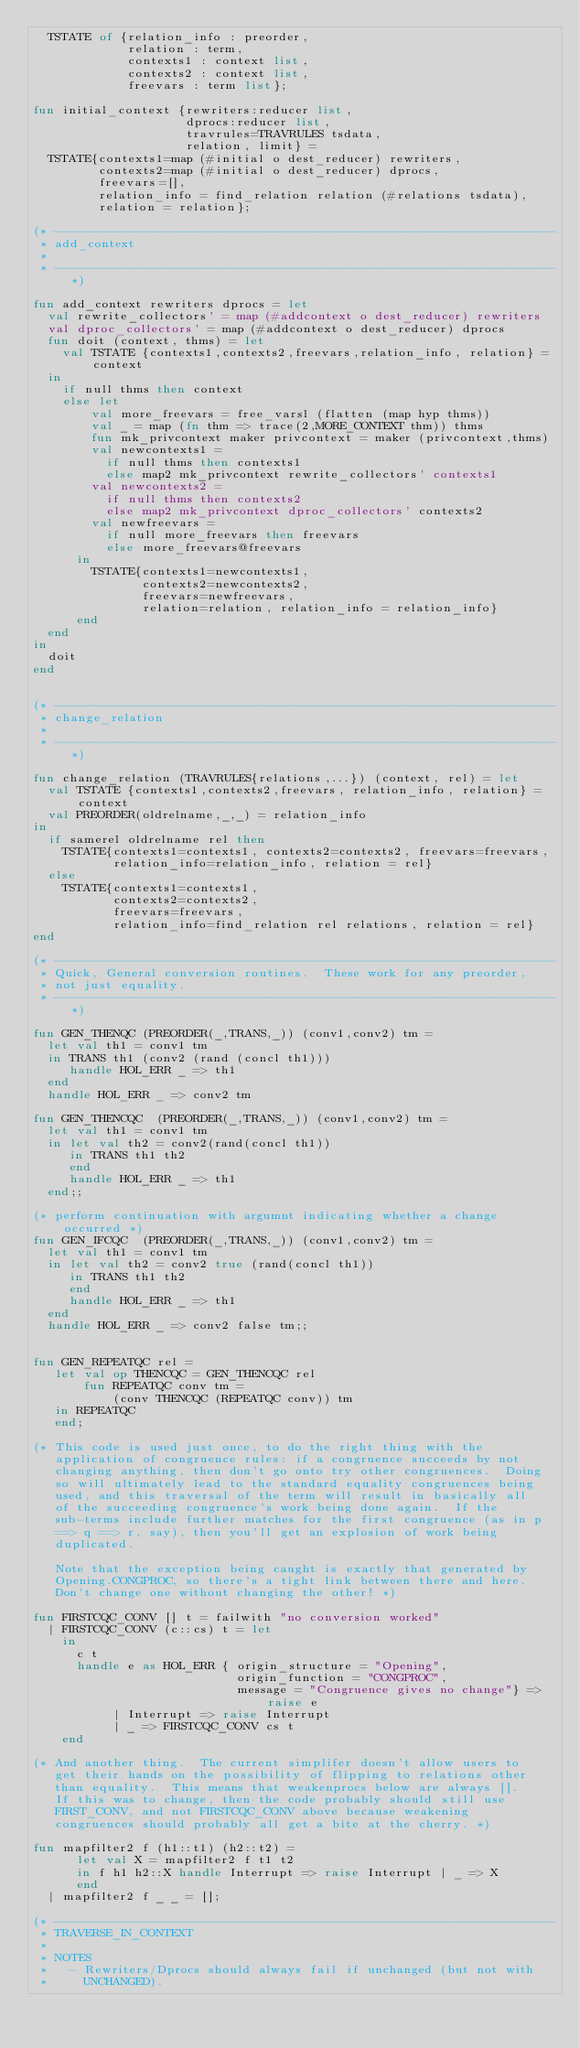<code> <loc_0><loc_0><loc_500><loc_500><_SML_>  TSTATE of {relation_info : preorder,
             relation : term,
             contexts1 : context list,
             contexts2 : context list,
             freevars : term list};

fun initial_context {rewriters:reducer list,
                     dprocs:reducer list,
                     travrules=TRAVRULES tsdata,
                     relation, limit} =
  TSTATE{contexts1=map (#initial o dest_reducer) rewriters,
         contexts2=map (#initial o dest_reducer) dprocs,
         freevars=[],
         relation_info = find_relation relation (#relations tsdata),
         relation = relation};

(* ---------------------------------------------------------------------
 * add_context
 *
 * ---------------------------------------------------------------------*)

fun add_context rewriters dprocs = let
  val rewrite_collectors' = map (#addcontext o dest_reducer) rewriters
  val dproc_collectors' = map (#addcontext o dest_reducer) dprocs
  fun doit (context, thms) = let
    val TSTATE {contexts1,contexts2,freevars,relation_info, relation} = context
  in
    if null thms then context
    else let
        val more_freevars = free_varsl (flatten (map hyp thms))
        val _ = map (fn thm => trace(2,MORE_CONTEXT thm)) thms
        fun mk_privcontext maker privcontext = maker (privcontext,thms)
        val newcontexts1 =
          if null thms then contexts1
          else map2 mk_privcontext rewrite_collectors' contexts1
        val newcontexts2 =
          if null thms then contexts2
          else map2 mk_privcontext dproc_collectors' contexts2
        val newfreevars =
          if null more_freevars then freevars
          else more_freevars@freevars
      in
        TSTATE{contexts1=newcontexts1,
               contexts2=newcontexts2,
               freevars=newfreevars,
               relation=relation, relation_info = relation_info}
      end
  end
in
  doit
end


(* ---------------------------------------------------------------------
 * change_relation
 *
 * ---------------------------------------------------------------------*)

fun change_relation (TRAVRULES{relations,...}) (context, rel) = let
  val TSTATE {contexts1,contexts2,freevars, relation_info, relation} = context
  val PREORDER(oldrelname,_,_) = relation_info
in
  if samerel oldrelname rel then
    TSTATE{contexts1=contexts1, contexts2=contexts2, freevars=freevars,
           relation_info=relation_info, relation = rel}
  else
    TSTATE{contexts1=contexts1,
           contexts2=contexts2,
           freevars=freevars,
           relation_info=find_relation rel relations, relation = rel}
end

(* ---------------------------------------------------------------------
 * Quick, General conversion routines.  These work for any preorder,
 * not just equality.
 * ---------------------------------------------------------------------*)

fun GEN_THENQC (PREORDER(_,TRANS,_)) (conv1,conv2) tm =
  let val th1 = conv1 tm
  in TRANS th1 (conv2 (rand (concl th1)))
     handle HOL_ERR _ => th1
  end
  handle HOL_ERR _ => conv2 tm

fun GEN_THENCQC  (PREORDER(_,TRANS,_)) (conv1,conv2) tm =
  let val th1 = conv1 tm
  in let val th2 = conv2(rand(concl th1))
     in TRANS th1 th2
     end
     handle HOL_ERR _ => th1
  end;;

(* perform continuation with argumnt indicating whether a change occurred *)
fun GEN_IFCQC  (PREORDER(_,TRANS,_)) (conv1,conv2) tm =
  let val th1 = conv1 tm
  in let val th2 = conv2 true (rand(concl th1))
     in TRANS th1 th2
     end
     handle HOL_ERR _ => th1
  end
  handle HOL_ERR _ => conv2 false tm;;


fun GEN_REPEATQC rel =
   let val op THENCQC = GEN_THENCQC rel
       fun REPEATQC conv tm =
           (conv THENCQC (REPEATQC conv)) tm
   in REPEATQC
   end;

(* This code is used just once, to do the right thing with the
   application of congruence rules: if a congruence succeeds by not
   changing anything, then don't go onto try other congruences.  Doing
   so will ultimately lead to the standard equality congruences being
   used, and this traversal of the term will result in basically all
   of the succeeding congruence's work being done again.  If the
   sub-terms include further matches for the first congruence (as in p
   ==> q ==> r, say), then you'll get an explosion of work being
   duplicated.

   Note that the exception being caught is exactly that generated by
   Opening.CONGPROC, so there's a tight link between there and here.
   Don't change one without changing the other! *)

fun FIRSTCQC_CONV [] t = failwith "no conversion worked"
  | FIRSTCQC_CONV (c::cs) t = let
    in
      c t
      handle e as HOL_ERR { origin_structure = "Opening",
                            origin_function = "CONGPROC",
                            message = "Congruence gives no change"} => raise e
           | Interrupt => raise Interrupt
           | _ => FIRSTCQC_CONV cs t
    end

(* And another thing.  The current simplifer doesn't allow users to
   get their hands on the possibility of flipping to relations other
   than equality.  This means that weakenprocs below are always [].
   If this was to change, then the code probably should still use
   FIRST_CONV, and not FIRSTCQC_CONV above because weakening
   congruences should probably all get a bite at the cherry. *)

fun mapfilter2 f (h1::t1) (h2::t2) =
      let val X = mapfilter2 f t1 t2
      in f h1 h2::X handle Interrupt => raise Interrupt | _ => X
      end
  | mapfilter2 f _ _ = [];

(* ---------------------------------------------------------------------
 * TRAVERSE_IN_CONTEXT
 *
 * NOTES
 *   - Rewriters/Dprocs should always fail if unchanged (but not with
 *     UNCHANGED).</code> 